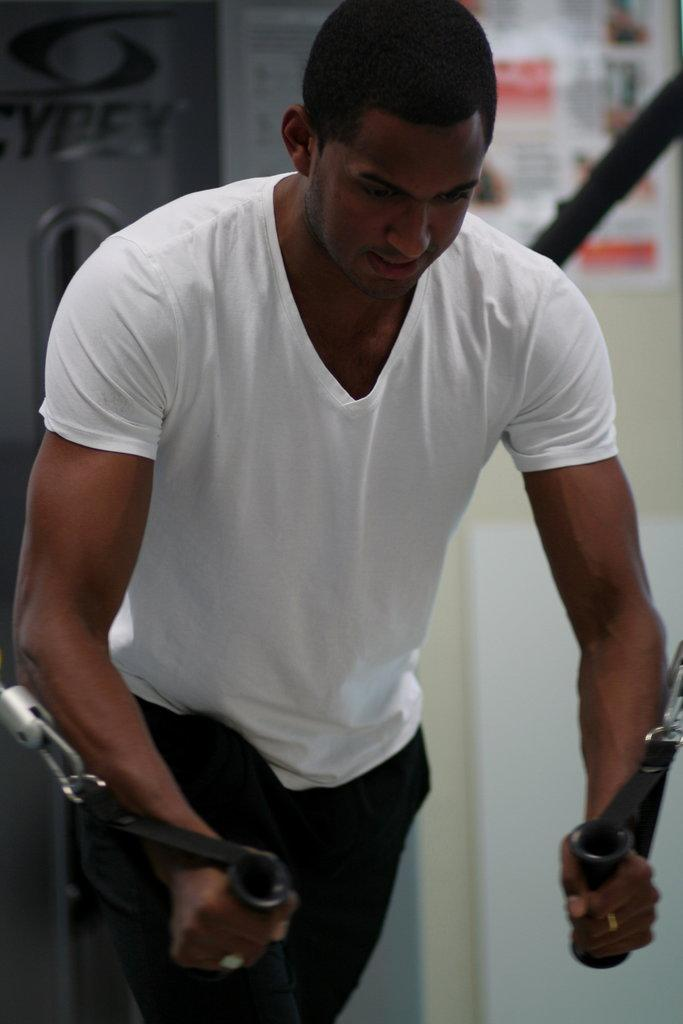Who is in the image? There is a man in the image. What is the man wearing? The man is wearing a white T-shirt. What is the man doing in the image? The man appears to be working out. What can be seen in the background of the image? There is a wall in the background of the image. What is on the wall in the image? There is a poster on the wall. What type of air is being used by the man to help him work out in the image? There is no air or any specific air-related equipment visible in the image. What type of celery is being used by the man as a prop in the image? There is no celery or any other vegetable present in the image. 